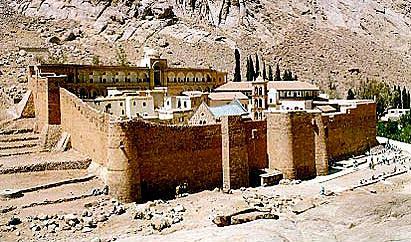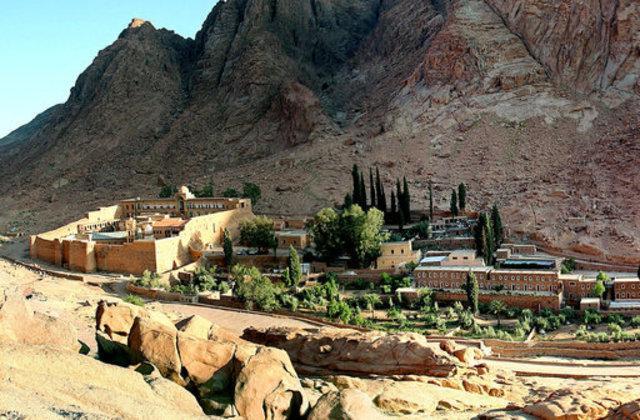The first image is the image on the left, the second image is the image on the right. Given the left and right images, does the statement "In at least one image there is a single castle facing forward." hold true? Answer yes or no. No. The first image is the image on the left, the second image is the image on the right. Evaluate the accuracy of this statement regarding the images: "All of the boundaries are shown for one walled city in each image.". Is it true? Answer yes or no. Yes. 